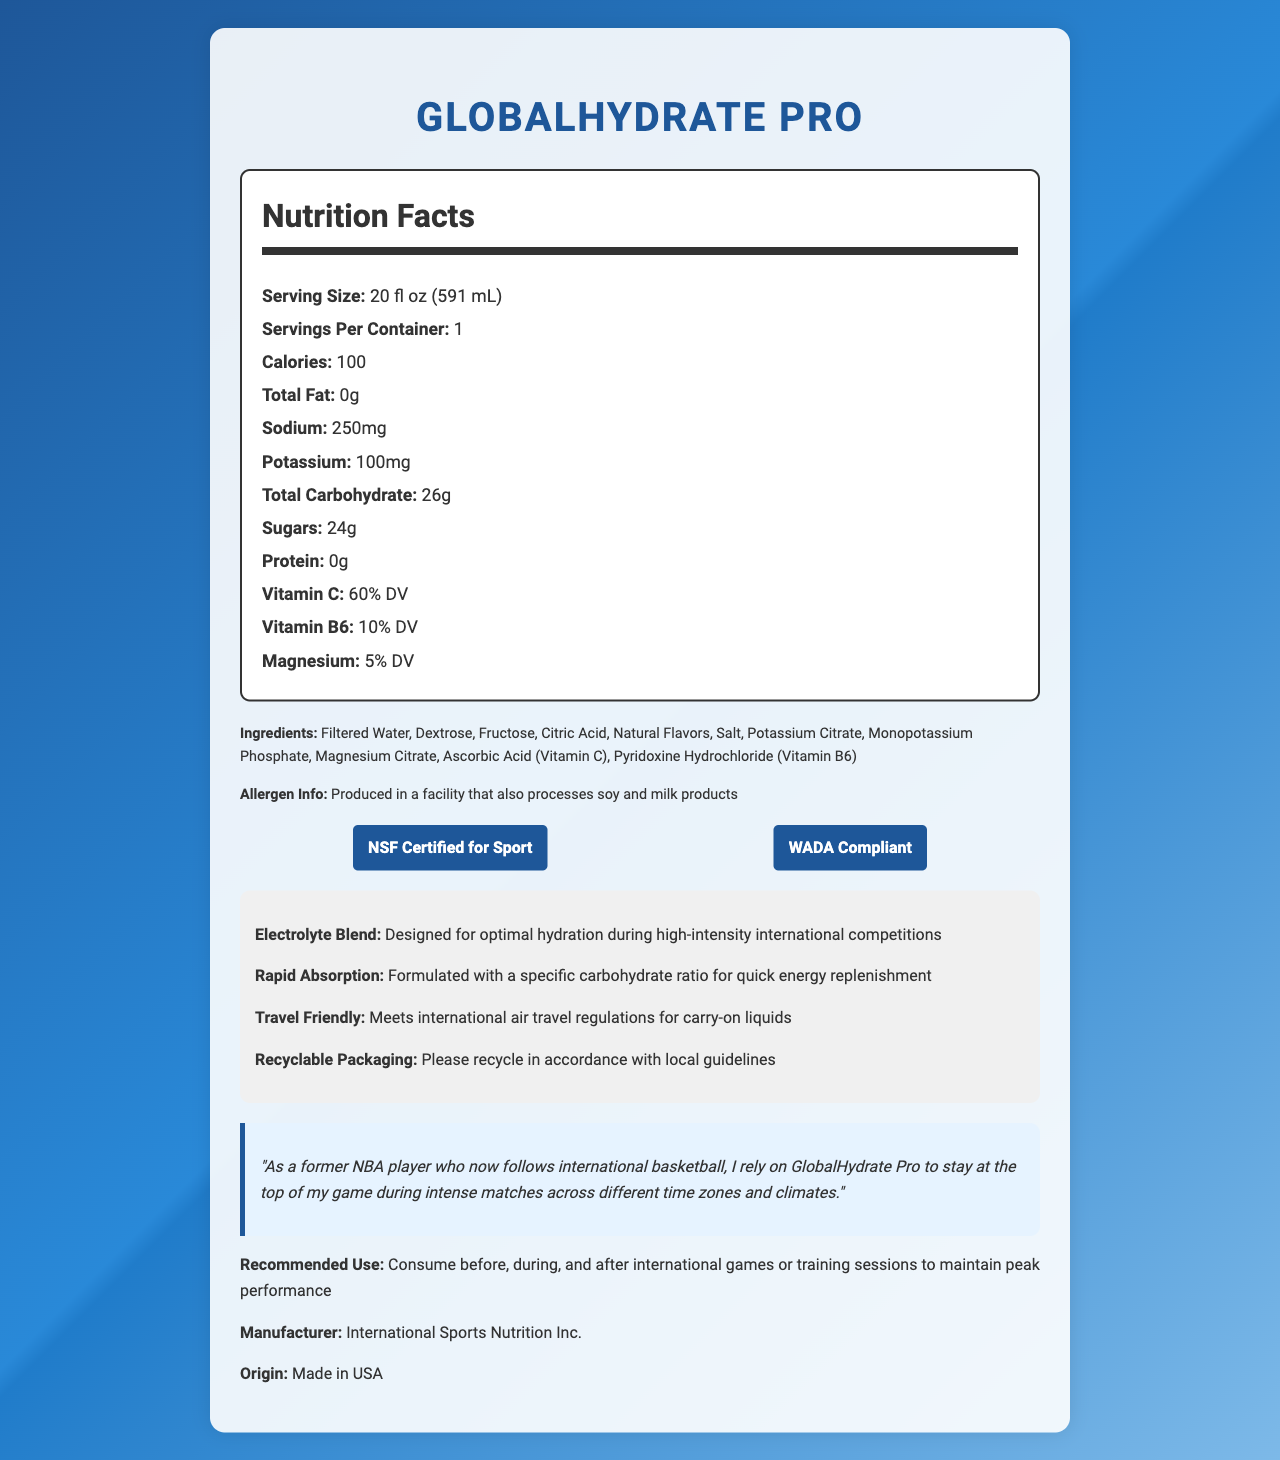what is the serving size? According to the Nutrition Facts Label, the serving size is listed as 20 fl oz (591 mL).
Answer: 20 fl oz (591 mL) how many calories are in one serving? The Nutrition Facts Label indicates that one serving contains 100 calories.
Answer: 100 calories what ingredients in "GlobalHydrate Pro" might provide electrolytes? These ingredients are known to provide essential electrolytes necessary for hydration.
Answer: Salt, Potassium Citrate, Monopotassium Phosphate, Magnesium Citrate which vitamins are included in "GlobalHydrate Pro" and what are their daily value percentages? The Nutrition Facts Label shows that Vitamin C provides 60% of the Daily Value and Vitamin B6 provides 10% of the Daily Value.
Answer: Vitamin C (60% DV), Vitamin B6 (10% DV) how much sugar does each serving of "GlobalHydrate Pro" contain? The sugar content per serving is listed as 24 grams on the Nutrition Facts Label.
Answer: 24g what certifications does GlobalHydrate Pro have? A. FDA Approved B. NSF Certified for Sport C. WADA Compliant D. USDA Organic The document lists "NSF Certified for Sport" and "WADA Compliant" as the certifications.
Answer: B. NSF Certified for Sport and C. WADA Compliant how many servings are in one container? The Nutrition Facts Label states that there is 1 serving per container.
Answer: 1 is "GlobalHydrate Pro" safe for soy and milk allergy sufferers? The allergen info indicates that it is produced in a facility that also processes soy and milk products.
Answer: No list the electrolytes and their respective amounts in "GlobalHydrate Pro" These electrolytes and their amounts are detailed in the Nutrition Facts section and the additional information provided.
Answer: Sodium: 250mg, Potassium: 100mg, Magnesium: 5% DV summarize the key points of GlobalHydrate Pro's Nutrition Facts Label This summary includes information about the nutritional content, ingredients, certifications, and intended use of GlobalHydrate Pro.
Answer: GlobalHydrate Pro is a sports drink designed for rapid hydration, with a serving size of 20 fl oz (591 mL). It contains 100 calories per serving, 0g of total fat, 250mg of sodium, 100mg of potassium, 26g of total carbohydrates (including 24g of sugars), and 0g of protein. The drink provides 60% DV of Vitamin C, 10% DV of Vitamin B6, and 5% DV of Magnesium. Ingredients include filtered water, dextrose, fructose, citric acid, and more. It is certified by NSF and WADA, suitable for high-intensity international competitions, and packaged for travel. An athlete testimonial endorses its use during intense matches. does "GlobalHydrate Pro" contain protein? The Nutrition Facts Label indicates that the protein content is 0 grams.
Answer: No where is GlobalHydrate Pro manufactured? The document specifies that the product is made in the USA.
Answer: Made in USA is the packaging recyclable? The additional information section mentions that the packaging is recyclable.
Answer: Yes how much total carbohydrate is in each serving? The total carbohydrate per serving is listed as 26 grams on the Nutrition Facts Label.
Answer: 26g what is the recommended use for "GlobalHydrate Pro"? The document provides this recommendation for optimal performance.
Answer: Consume before, during, and after international games or training sessions to maintain peak performance who is the manufacturer of "GlobalHydrate Pro"? According to the document, International Sports Nutrition Inc. manufactures GlobalHydrate Pro.
Answer: International Sports Nutrition Inc. what is the main purpose of the carbohydrate ratio in "GlobalHydrate Pro"? The additional information states that it is formulated with a specific carbohydrate ratio for quick energy replenishment.
Answer: Quick energy replenishment is "GlobalHydrate Pro" FDA approved? The document does not mention FDA approval for GlobalHydrate Pro.
Answer: Not enough information 